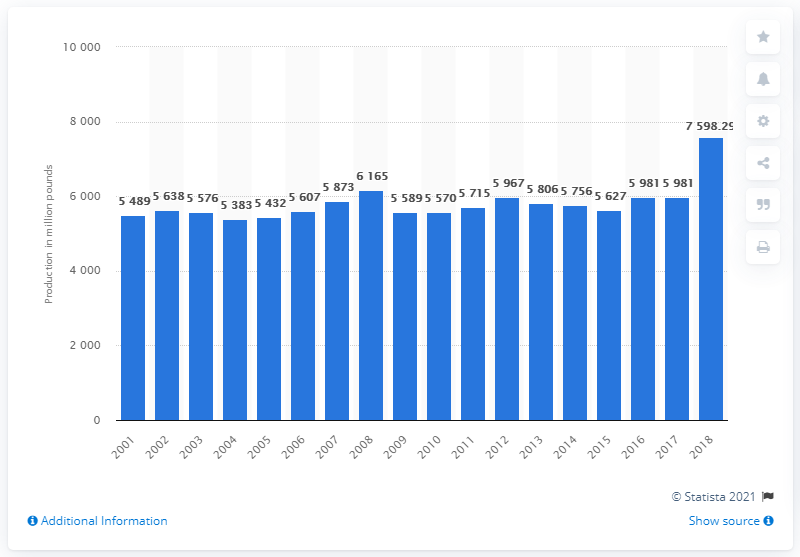Specify some key components in this picture. In the year 2018, a total of 7,598.29 metric tons of turkey was produced in the United States. 